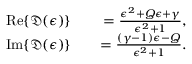Convert formula to latex. <formula><loc_0><loc_0><loc_500><loc_500>\begin{array} { r l r } { R e \{ \mathfrak { D } ( \epsilon ) \} } & { = \frac { \epsilon ^ { 2 } + Q \epsilon + \gamma } { \epsilon ^ { 2 } + 1 } , } \\ { I m \{ \mathfrak { D } ( \epsilon ) \} } & { = \frac { ( \gamma - 1 ) \epsilon - Q } { \epsilon ^ { 2 } + 1 } . } \end{array}</formula> 